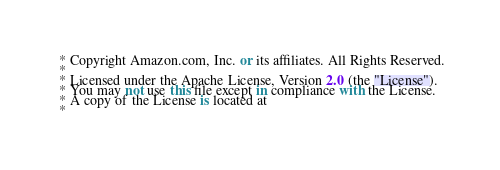<code> <loc_0><loc_0><loc_500><loc_500><_C#_> * Copyright Amazon.com, Inc. or its affiliates. All Rights Reserved.
 * 
 * Licensed under the Apache License, Version 2.0 (the "License").
 * You may not use this file except in compliance with the License.
 * A copy of the License is located at
 * </code> 